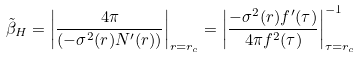<formula> <loc_0><loc_0><loc_500><loc_500>\tilde { \beta } _ { H } = \left | \frac { 4 \pi } { ( - \sigma ^ { 2 } ( r ) N ^ { \prime } ( r ) ) } \right | _ { r = r _ { c } } = \left | \frac { - \sigma ^ { 2 } ( r ) f ^ { \prime } ( \tau ) } { 4 \pi f ^ { 2 } ( \tau ) } \right | _ { \tau = r _ { c } } ^ { - 1 }</formula> 